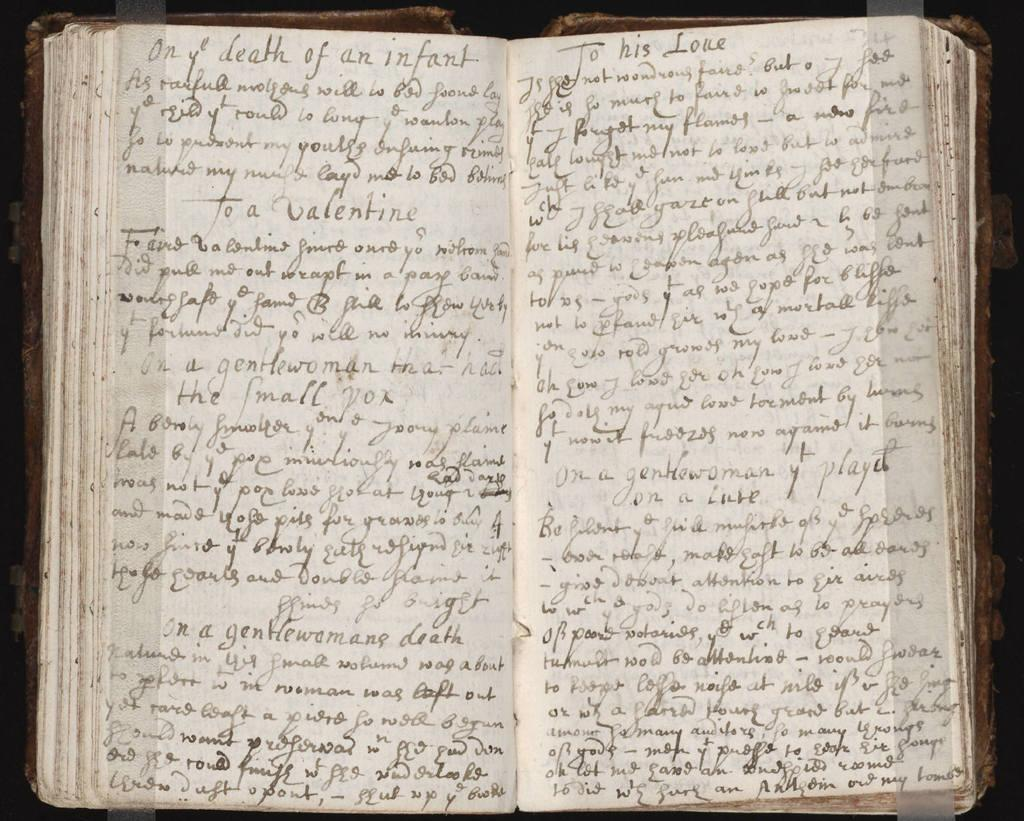<image>
Relay a brief, clear account of the picture shown. A handwritten journal is open to a page that begins with "only death of an infant." 